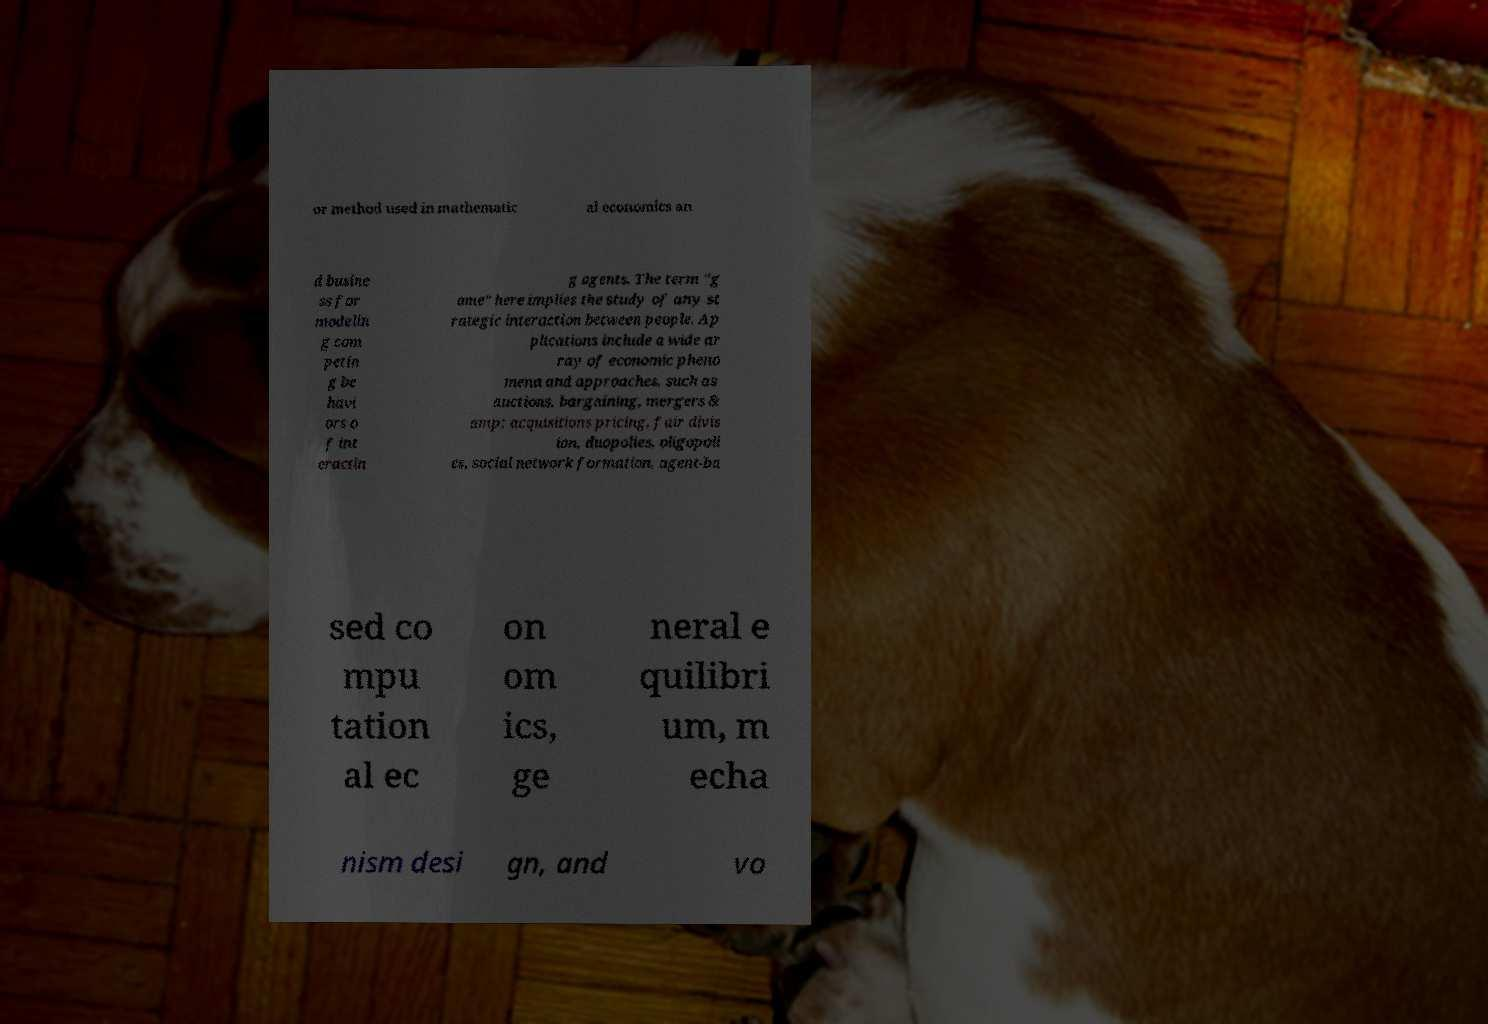Please read and relay the text visible in this image. What does it say? or method used in mathematic al economics an d busine ss for modelin g com petin g be havi ors o f int eractin g agents. The term "g ame" here implies the study of any st rategic interaction between people. Ap plications include a wide ar ray of economic pheno mena and approaches, such as auctions, bargaining, mergers & amp; acquisitions pricing, fair divis ion, duopolies, oligopoli es, social network formation, agent-ba sed co mpu tation al ec on om ics, ge neral e quilibri um, m echa nism desi gn, and vo 